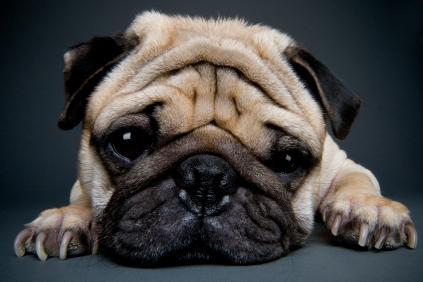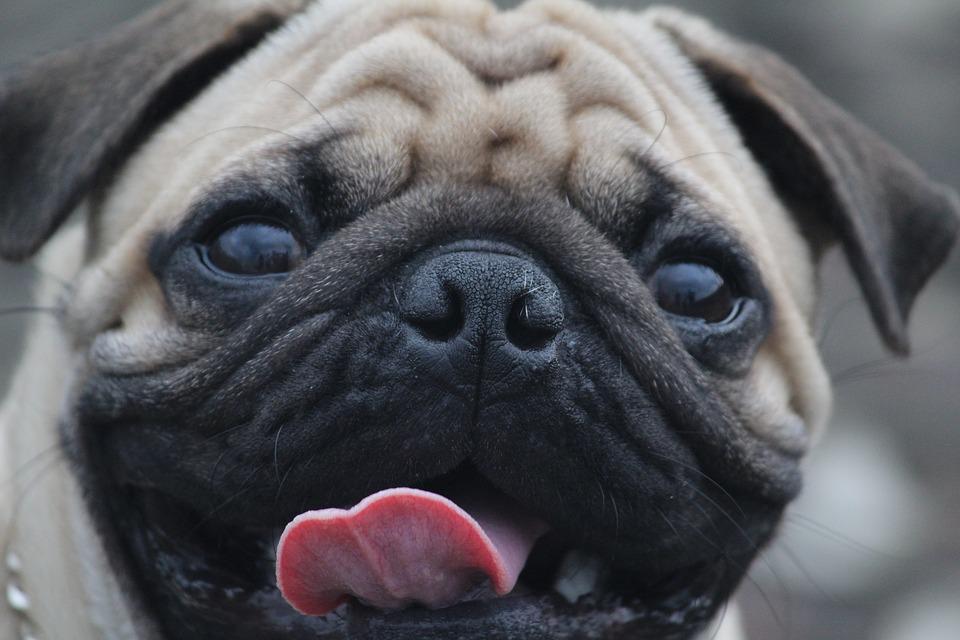The first image is the image on the left, the second image is the image on the right. Analyze the images presented: Is the assertion "The pug reclining in the right image has paws extended in front." valid? Answer yes or no. No. 